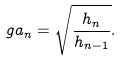Convert formula to latex. <formula><loc_0><loc_0><loc_500><loc_500>\ g a _ { n } = \sqrt { \frac { h _ { n } } { h _ { n - 1 } } } .</formula> 